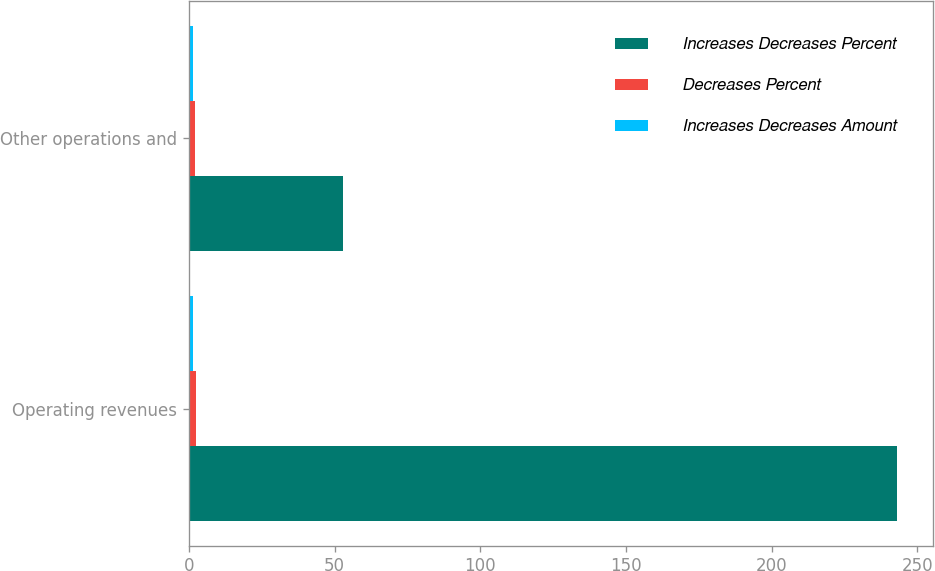<chart> <loc_0><loc_0><loc_500><loc_500><stacked_bar_chart><ecel><fcel>Operating revenues<fcel>Other operations and<nl><fcel>Increases Decreases Percent<fcel>243<fcel>53<nl><fcel>Decreases Percent<fcel>2.4<fcel>1.9<nl><fcel>Increases Decreases Amount<fcel>1.4<fcel>1.4<nl></chart> 